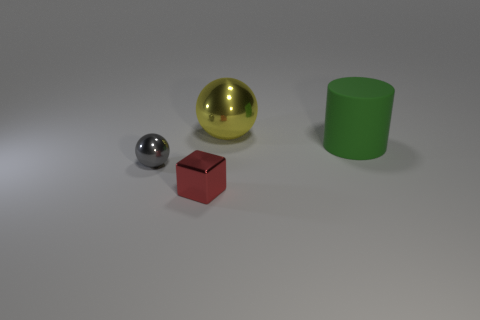Are there any other things that have the same material as the green thing?
Provide a short and direct response. No. Is there any other thing that has the same shape as the large matte object?
Provide a succinct answer. No. What is the material of the small object behind the tiny red block?
Offer a terse response. Metal. Is there anything else that is the same size as the cylinder?
Offer a very short reply. Yes. There is a big yellow sphere; are there any spheres left of it?
Ensure brevity in your answer.  Yes. The large rubber thing has what shape?
Keep it short and to the point. Cylinder. What number of objects are tiny objects in front of the tiny gray shiny object or tiny purple matte things?
Give a very brief answer. 1. How many other things are the same color as the big matte cylinder?
Your answer should be compact. 0. Is the color of the matte cylinder the same as the ball that is to the left of the large metallic object?
Your answer should be very brief. No. What color is the small thing that is the same shape as the large metal thing?
Offer a very short reply. Gray. 